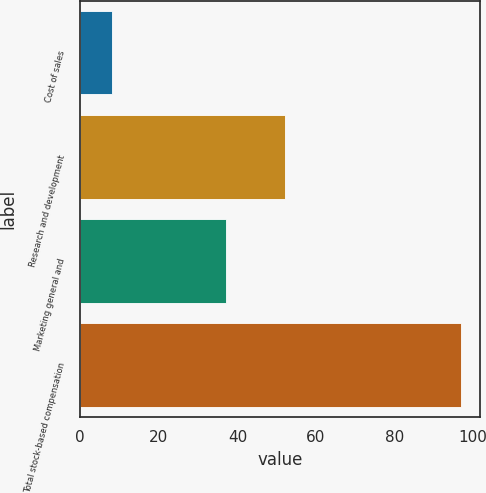Convert chart. <chart><loc_0><loc_0><loc_500><loc_500><bar_chart><fcel>Cost of sales<fcel>Research and development<fcel>Marketing general and<fcel>Total stock-based compensation<nl><fcel>8<fcel>52<fcel>37<fcel>97<nl></chart> 